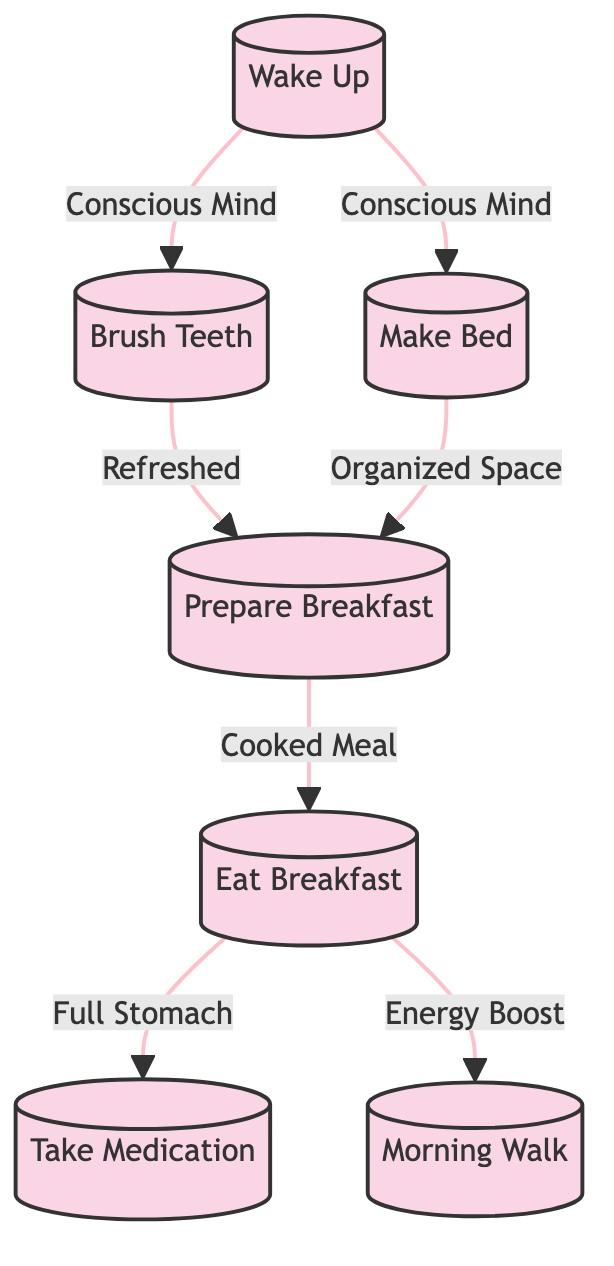What is the first activity in the morning routine? The first activity listed in the diagram is labeled "Wake Up," indicating the start of the morning routine.
Answer: Wake Up How many processes are shown in the diagram? To find the number of processes, we can count the activities listed: Wake Up, Brush Teeth, Make Bed, Prepare Breakfast, Eat Breakfast, Take Medication, and Morning Walk. There are seven processes total.
Answer: 7 Which activity follows "Brush Teeth"? According to the data flow in the diagram, "Brush Teeth" leads to "Prepare Breakfast," indicating that this is the subsequent activity.
Answer: Prepare Breakfast What is the data flow between "Eat Breakfast" and "Take Medication"? The diagram shows a data flow stemming from "Eat Breakfast" to "Take Medication," represented by the data "Full Stomach," indicating that the experience of eating breakfast influences taking medication.
Answer: Full Stomach Which two activities are completed after "Wake Up"? The diagram illustrates that "Wake Up" leads to both "Brush Teeth" and "Make Bed," indicating these activities are carried out after waking up.
Answer: Brush Teeth, Make Bed What data flows into "Prepare Breakfast"? Both "Brush Teeth" and "Make Bed" flow into "Prepare Breakfast," with the respective data of being "Refreshed" and "Organized Space." This means that having good oral hygiene and a tidy room contributes to preparing breakfast.
Answer: Refreshed, Organized Space What is the last activity in the daily routine? The final activity in the morning routine as represented in the diagram is "Morning Walk," marking it as the concluding task of the flow.
Answer: Morning Walk Which activity is associated with "Cooked Meal"? The data flow shows that "Cooked Meal" is associated with the activity "Eat Breakfast," as this is the meal that is prepared to be enjoyed after cooking.
Answer: Eat Breakfast How does "Eat Breakfast" affect the next activities? "Eat Breakfast" influences both "Take Medication" and "Morning Walk," providing the necessary data of "Full Stomach" and "Energy Boost" for these subsequent activities, thus linking them together.
Answer: Take Medication, Morning Walk 